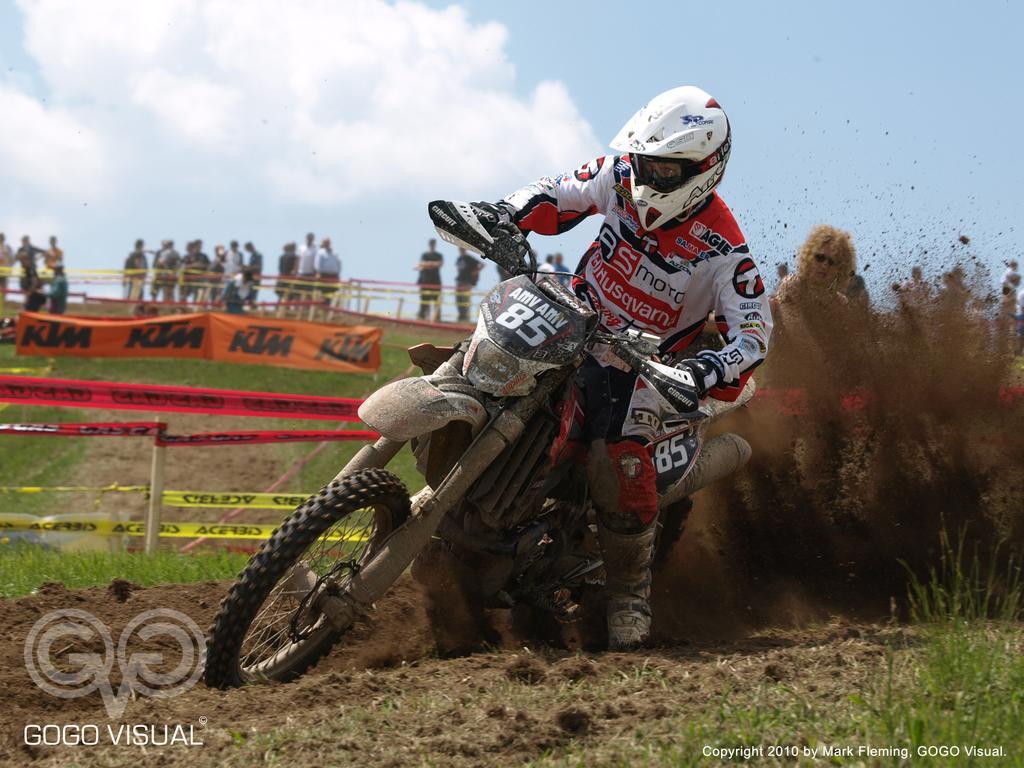Please provide a concise description of this image. This picture shows a human riding a motorcycle. We see helmet on the head and we see mud and grass on the ground and few people standing and a blue cloudy sky and a watermark at the bottom left of the picture. 